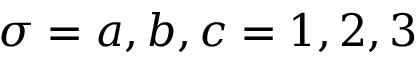Convert formula to latex. <formula><loc_0><loc_0><loc_500><loc_500>\sigma = a , b , c = 1 , 2 , 3</formula> 